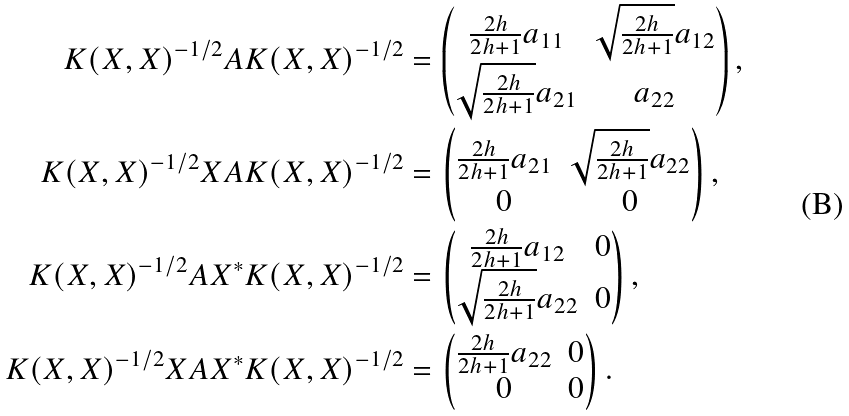<formula> <loc_0><loc_0><loc_500><loc_500>K ( X , X ) ^ { - 1 / 2 } A K ( X , X ) ^ { - 1 / 2 } & = \begin{pmatrix} \frac { 2 h } { 2 h + 1 } a _ { 1 1 } & \sqrt { \frac { 2 h } { 2 h + 1 } } a _ { 1 2 } \\ \sqrt { \frac { 2 h } { 2 h + 1 } } a _ { 2 1 } & a _ { 2 2 } \end{pmatrix} , \\ K ( X , X ) ^ { - 1 / 2 } X A K ( X , X ) ^ { - 1 / 2 } & = \begin{pmatrix} \frac { 2 h } { 2 h + 1 } a _ { 2 1 } & \sqrt { \frac { 2 h } { 2 h + 1 } } a _ { 2 2 } \\ 0 & 0 \end{pmatrix} , \\ K ( X , X ) ^ { - 1 / 2 } A X ^ { * } K ( X , X ) ^ { - 1 / 2 } & = \begin{pmatrix} \frac { 2 h } { 2 h + 1 } a _ { 1 2 } & 0 \\ \sqrt { \frac { 2 h } { 2 h + 1 } } a _ { 2 2 } & 0 \end{pmatrix} , \\ K ( X , X ) ^ { - 1 / 2 } X A X ^ { * } K ( X , X ) ^ { - 1 / 2 } & = \begin{pmatrix} \frac { 2 h } { 2 h + 1 } a _ { 2 2 } & 0 \\ 0 & 0 \end{pmatrix} .</formula> 